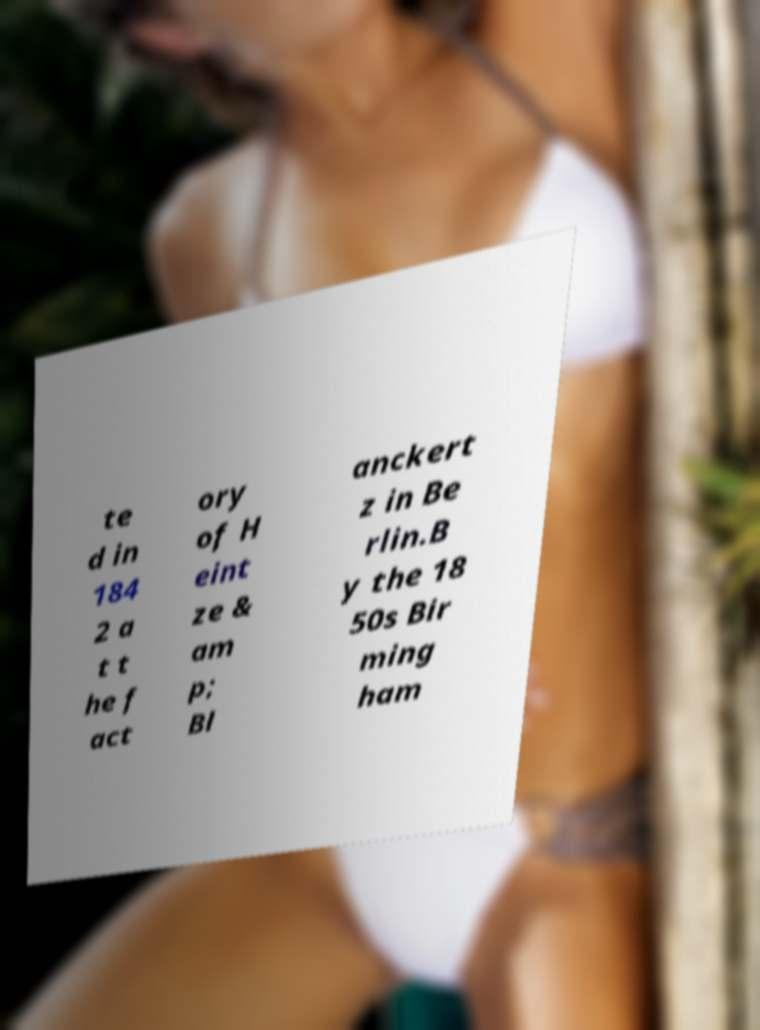There's text embedded in this image that I need extracted. Can you transcribe it verbatim? te d in 184 2 a t t he f act ory of H eint ze & am p; Bl anckert z in Be rlin.B y the 18 50s Bir ming ham 